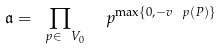<formula> <loc_0><loc_0><loc_500><loc_500>\mathfrak a = \prod _ { \ p \in \ V _ { 0 } } \ \ p ^ { \max \{ 0 , - v _ { \ } p ( P ) \} }</formula> 